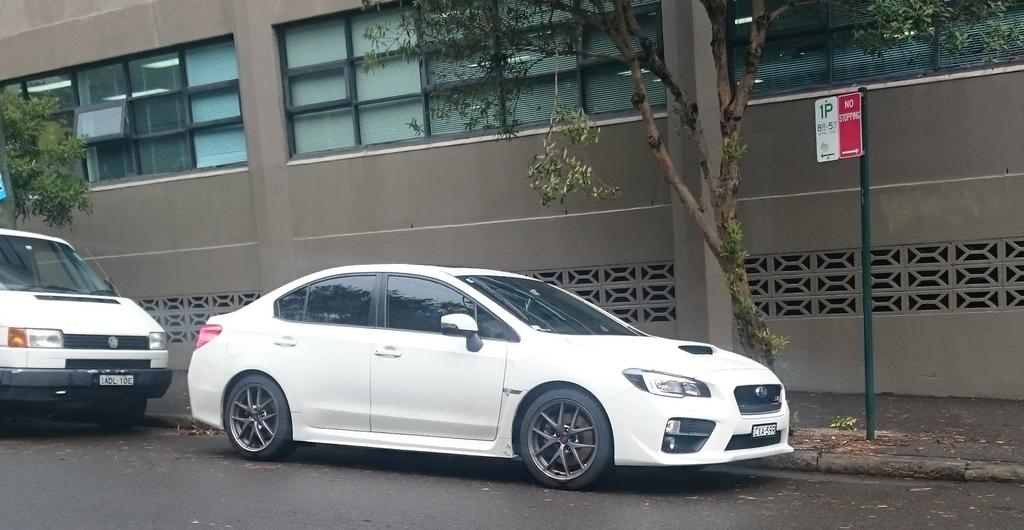What type of vehicles can be seen on the road in the image? There are cars on the road in the image. What is located beside the cars on the road? There are trees beside the cars. What is the purpose of the sign board in the image? The purpose of the sign board in the image is to provide information or directions. What material is the metal rod made of in the image? The metal rod in the image is made of metal. What type of structure is visible in the image? There is a building in the image. How many bars of soap are stacked on the building in the image? There are no bars of soap visible on the building in the image. What type of clocks can be seen hanging from the trees beside the cars? There are no clocks hanging from the trees beside the cars in the image. 